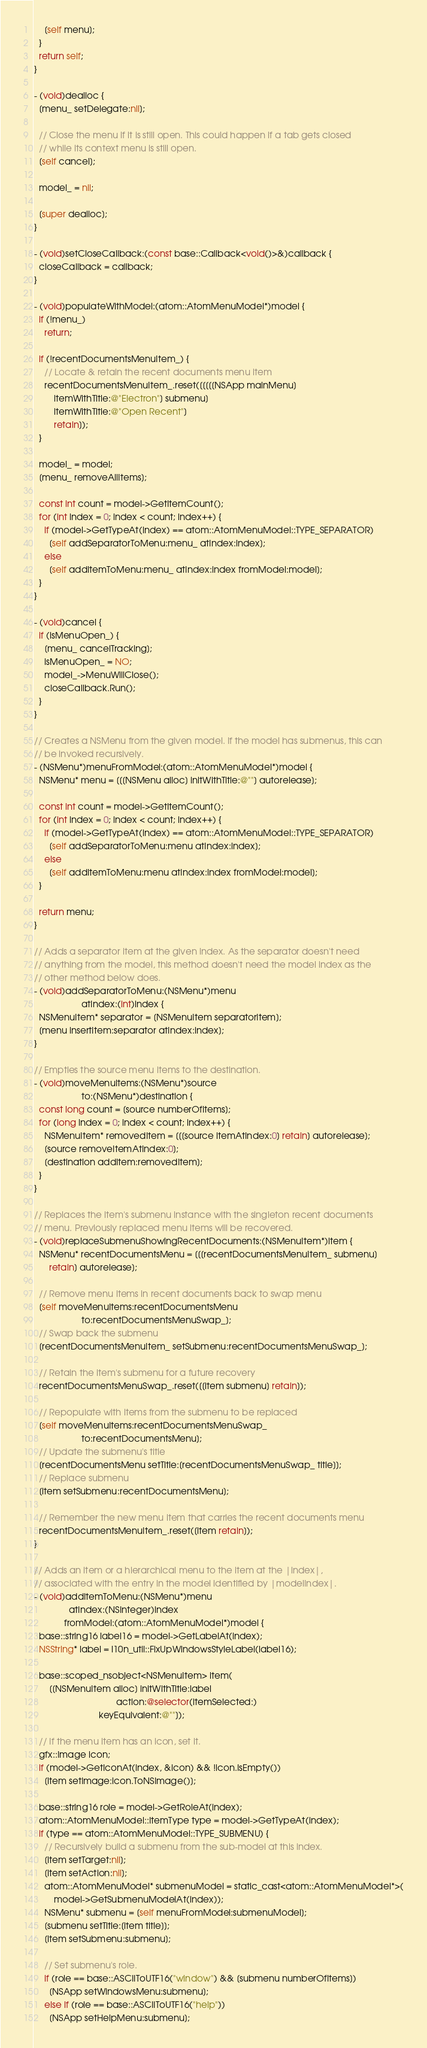<code> <loc_0><loc_0><loc_500><loc_500><_ObjectiveC_>    [self menu];
  }
  return self;
}

- (void)dealloc {
  [menu_ setDelegate:nil];

  // Close the menu if it is still open. This could happen if a tab gets closed
  // while its context menu is still open.
  [self cancel];

  model_ = nil;

  [super dealloc];
}

- (void)setCloseCallback:(const base::Callback<void()>&)callback {
  closeCallback = callback;
}

- (void)populateWithModel:(atom::AtomMenuModel*)model {
  if (!menu_)
    return;

  if (!recentDocumentsMenuItem_) {
    // Locate & retain the recent documents menu item
    recentDocumentsMenuItem_.reset([[[[[NSApp mainMenu]
        itemWithTitle:@"Electron"] submenu]
        itemWithTitle:@"Open Recent"]
        retain]);
  }

  model_ = model;
  [menu_ removeAllItems];

  const int count = model->GetItemCount();
  for (int index = 0; index < count; index++) {
    if (model->GetTypeAt(index) == atom::AtomMenuModel::TYPE_SEPARATOR)
      [self addSeparatorToMenu:menu_ atIndex:index];
    else
      [self addItemToMenu:menu_ atIndex:index fromModel:model];
  }
}

- (void)cancel {
  if (isMenuOpen_) {
    [menu_ cancelTracking];
    isMenuOpen_ = NO;
    model_->MenuWillClose();
    closeCallback.Run();
  }
}

// Creates a NSMenu from the given model. If the model has submenus, this can
// be invoked recursively.
- (NSMenu*)menuFromModel:(atom::AtomMenuModel*)model {
  NSMenu* menu = [[[NSMenu alloc] initWithTitle:@""] autorelease];

  const int count = model->GetItemCount();
  for (int index = 0; index < count; index++) {
    if (model->GetTypeAt(index) == atom::AtomMenuModel::TYPE_SEPARATOR)
      [self addSeparatorToMenu:menu atIndex:index];
    else
      [self addItemToMenu:menu atIndex:index fromModel:model];
  }

  return menu;
}

// Adds a separator item at the given index. As the separator doesn't need
// anything from the model, this method doesn't need the model index as the
// other method below does.
- (void)addSeparatorToMenu:(NSMenu*)menu
                   atIndex:(int)index {
  NSMenuItem* separator = [NSMenuItem separatorItem];
  [menu insertItem:separator atIndex:index];
}

// Empties the source menu items to the destination.
- (void)moveMenuItems:(NSMenu*)source
                   to:(NSMenu*)destination {
  const long count = [source numberOfItems];
  for (long index = 0; index < count; index++) {
    NSMenuItem* removedItem = [[[source itemAtIndex:0] retain] autorelease];
    [source removeItemAtIndex:0];
    [destination addItem:removedItem];
  }
}

// Replaces the item's submenu instance with the singleton recent documents
// menu. Previously replaced menu items will be recovered.
- (void)replaceSubmenuShowingRecentDocuments:(NSMenuItem*)item {
  NSMenu* recentDocumentsMenu = [[[recentDocumentsMenuItem_ submenu]
      retain] autorelease];

  // Remove menu items in recent documents back to swap menu
  [self moveMenuItems:recentDocumentsMenu
                   to:recentDocumentsMenuSwap_];
  // Swap back the submenu
  [recentDocumentsMenuItem_ setSubmenu:recentDocumentsMenuSwap_];

  // Retain the item's submenu for a future recovery
  recentDocumentsMenuSwap_.reset([[item submenu] retain]);

  // Repopulate with items from the submenu to be replaced
  [self moveMenuItems:recentDocumentsMenuSwap_
                   to:recentDocumentsMenu];
  // Update the submenu's title
  [recentDocumentsMenu setTitle:[recentDocumentsMenuSwap_ title]];
  // Replace submenu
  [item setSubmenu:recentDocumentsMenu];

  // Remember the new menu item that carries the recent documents menu
  recentDocumentsMenuItem_.reset([item retain]);
}

// Adds an item or a hierarchical menu to the item at the |index|,
// associated with the entry in the model identified by |modelIndex|.
- (void)addItemToMenu:(NSMenu*)menu
              atIndex:(NSInteger)index
            fromModel:(atom::AtomMenuModel*)model {
  base::string16 label16 = model->GetLabelAt(index);
  NSString* label = l10n_util::FixUpWindowsStyleLabel(label16);

  base::scoped_nsobject<NSMenuItem> item(
      [[NSMenuItem alloc] initWithTitle:label
                                 action:@selector(itemSelected:)
                          keyEquivalent:@""]);

  // If the menu item has an icon, set it.
  gfx::Image icon;
  if (model->GetIconAt(index, &icon) && !icon.IsEmpty())
    [item setImage:icon.ToNSImage()];

  base::string16 role = model->GetRoleAt(index);
  atom::AtomMenuModel::ItemType type = model->GetTypeAt(index);
  if (type == atom::AtomMenuModel::TYPE_SUBMENU) {
    // Recursively build a submenu from the sub-model at this index.
    [item setTarget:nil];
    [item setAction:nil];
    atom::AtomMenuModel* submenuModel = static_cast<atom::AtomMenuModel*>(
        model->GetSubmenuModelAt(index));
    NSMenu* submenu = [self menuFromModel:submenuModel];
    [submenu setTitle:[item title]];
    [item setSubmenu:submenu];

    // Set submenu's role.
    if (role == base::ASCIIToUTF16("window") && [submenu numberOfItems])
      [NSApp setWindowsMenu:submenu];
    else if (role == base::ASCIIToUTF16("help"))
      [NSApp setHelpMenu:submenu];</code> 